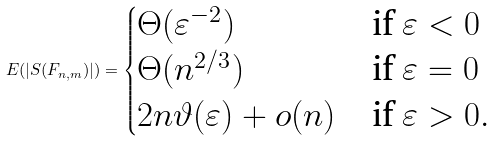Convert formula to latex. <formula><loc_0><loc_0><loc_500><loc_500>E ( | S ( F _ { n , m } ) | ) = \begin{cases} \Theta ( \varepsilon ^ { - 2 } ) & \text {if $ \varepsilon < 0$} \\ \Theta ( n ^ { 2 / 3 } ) & \text {if $ \varepsilon = 0$} \\ 2 n \vartheta ( \varepsilon ) + o ( n ) & \text {if $ \varepsilon > 0$} . \end{cases}</formula> 